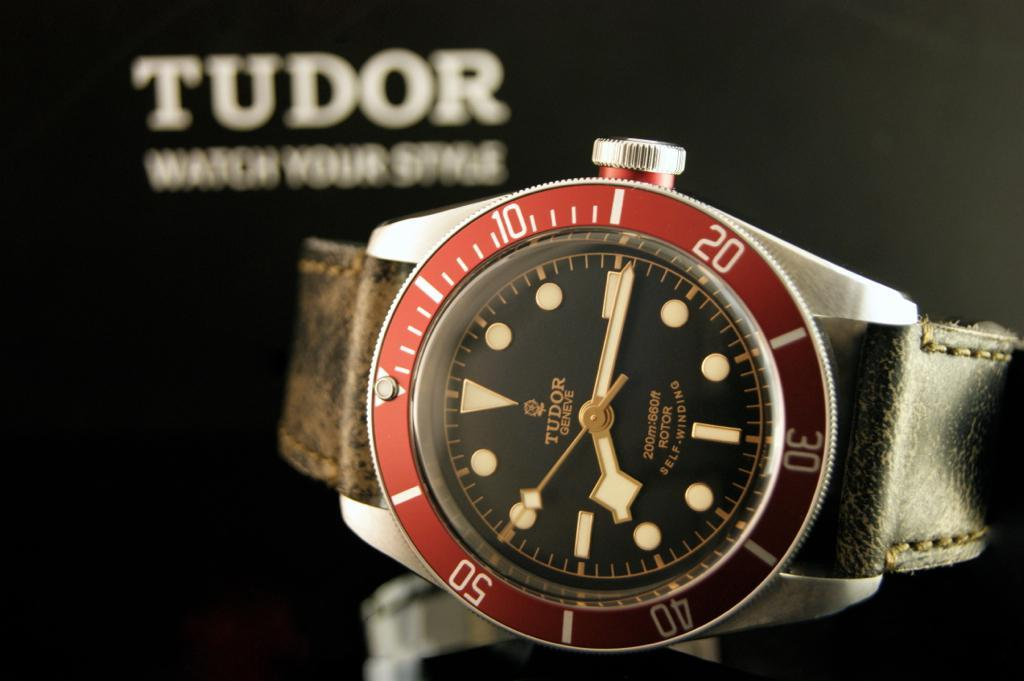<image>
Summarize the visual content of the image. A Tudor wrist watch is laying on its side. 